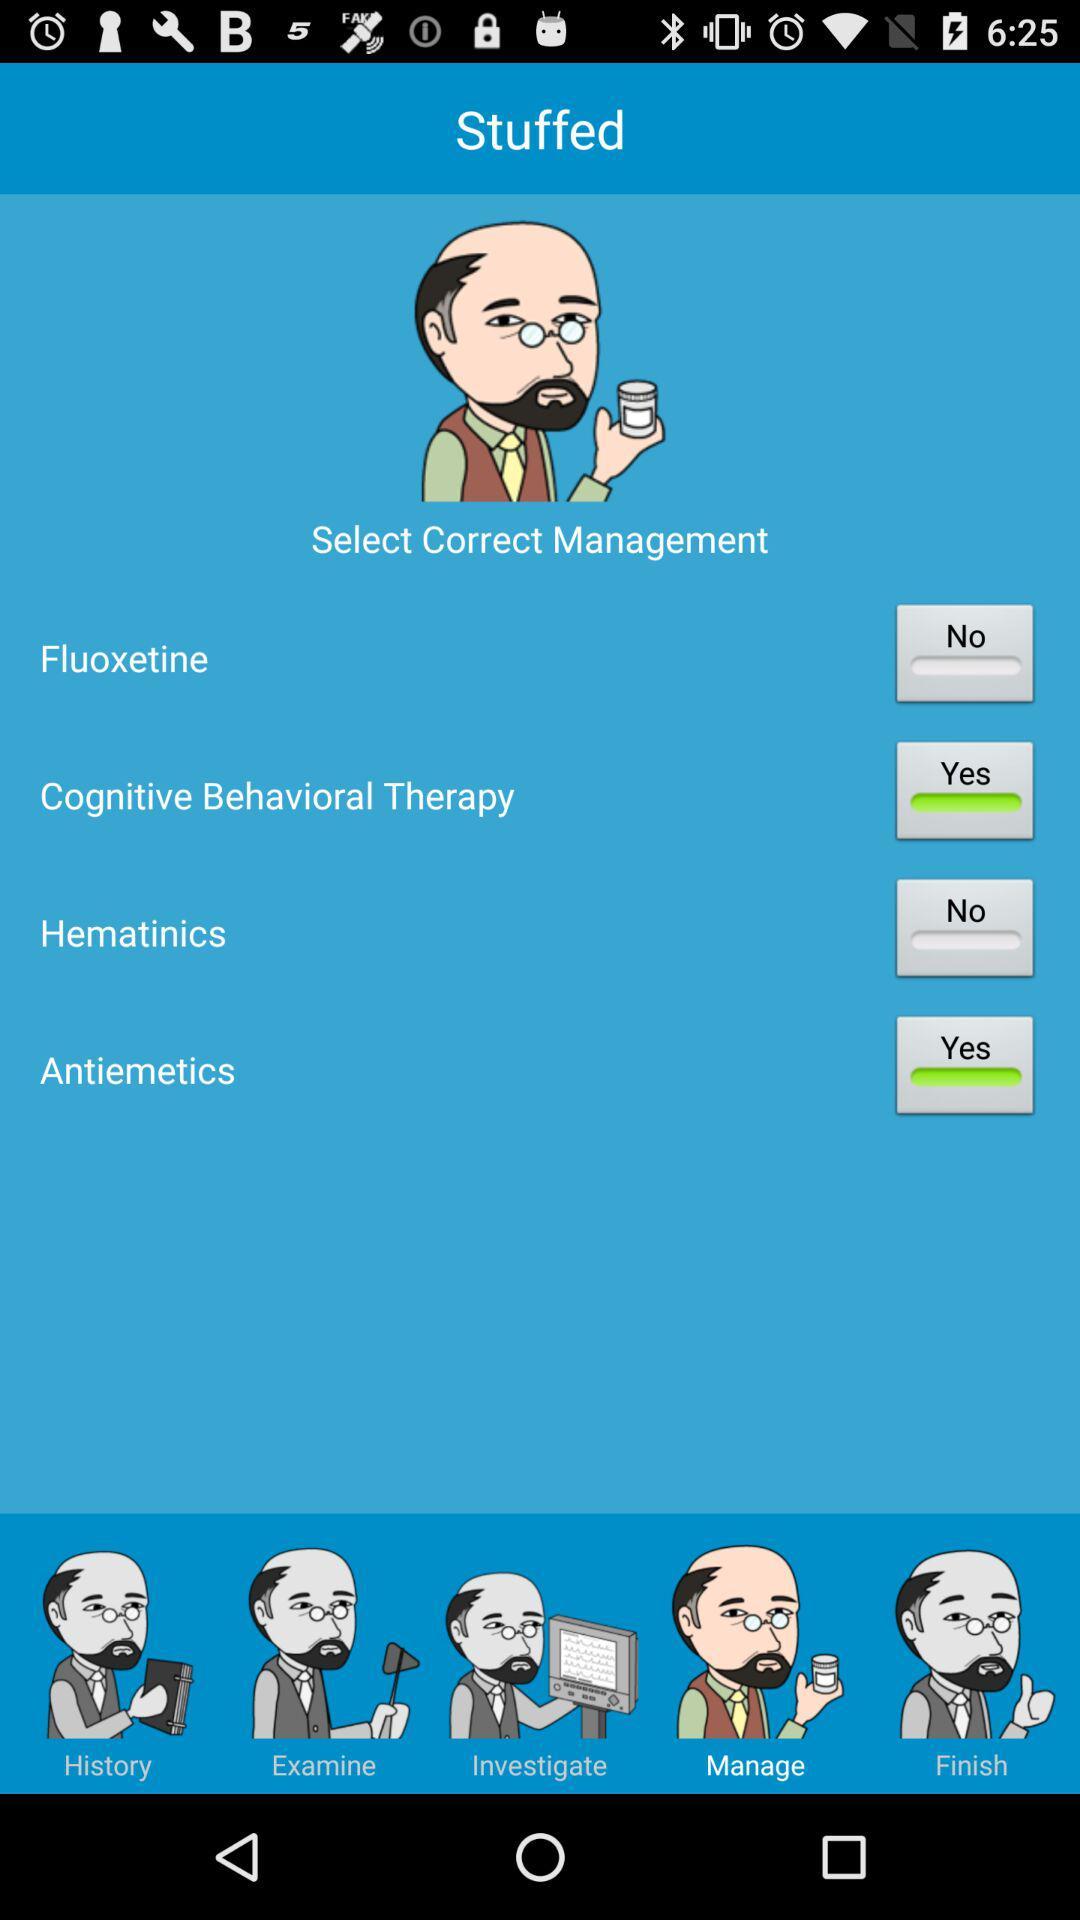How many management options are there?
Answer the question using a single word or phrase. 4 